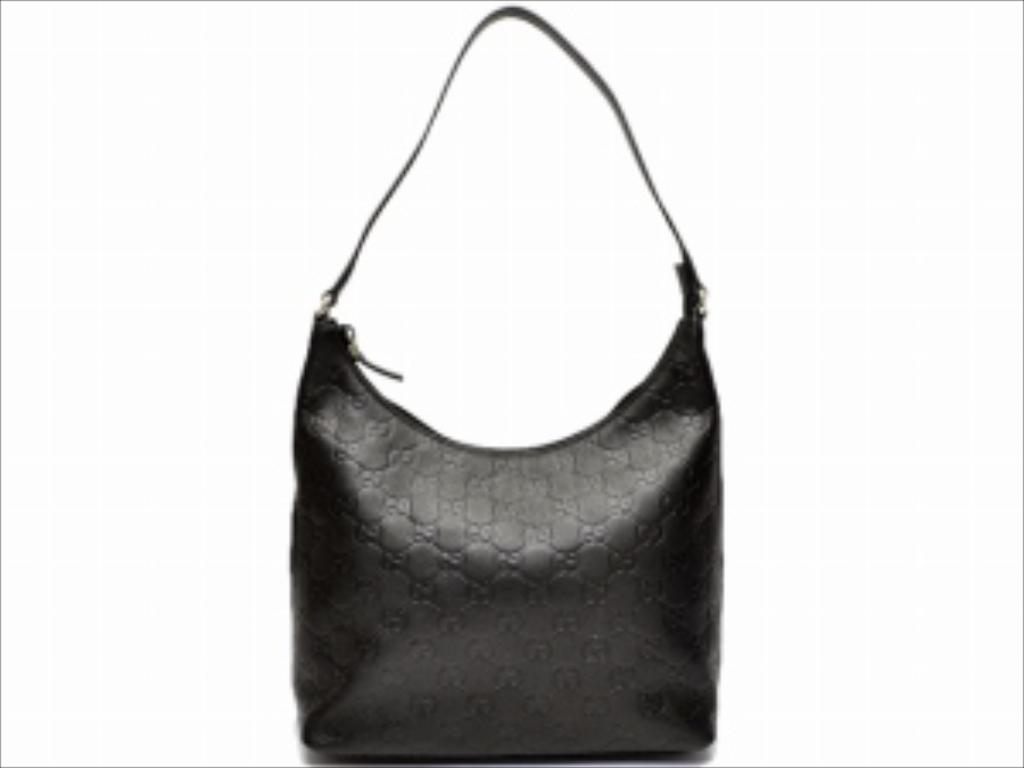What object can be seen in the image? There is a handbag in the image. Where is the library located in the image? There is no library present in the image; it only features a handbag. What type of territory is depicted in the image? The image does not depict any territory; it only features a handbag. 